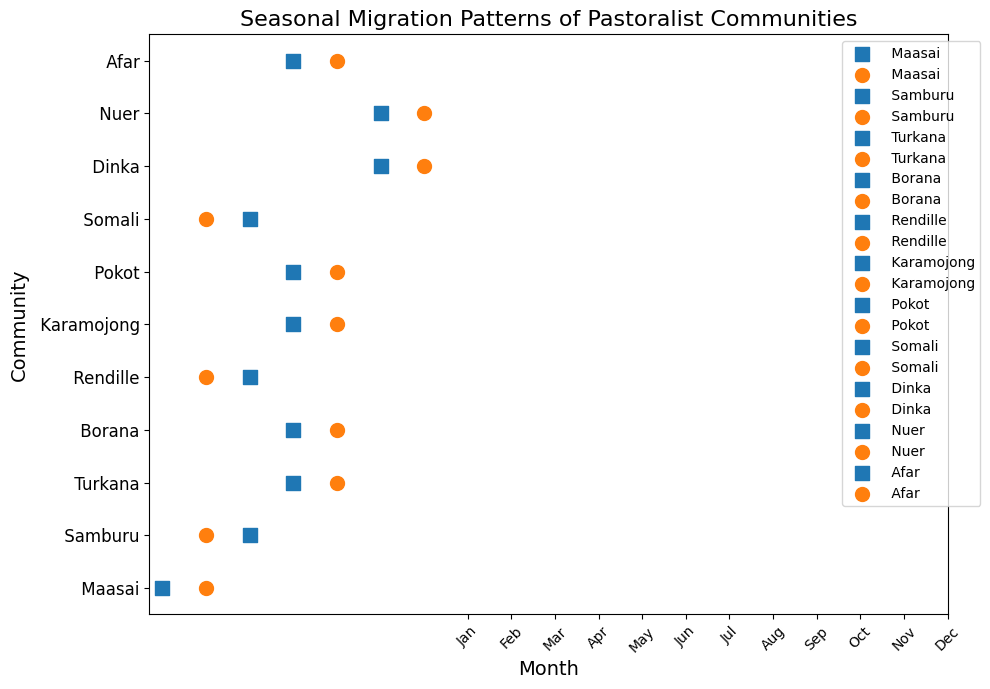Which community moves to dry season pastures the earliest in the year? From the scatter plot, observe that the first movement to dry season pastures occurs with the Dinka and Nuer communities in February.
Answer: Dinka and Nuer When do the Maasai community move to wet season pastures? In the scatter plot, locate the Maasai community row and find the month denoted with an orange circle. This occurs in November.
Answer: November Which communities move to dry season pastures in June? Identify the rows for June and note the communities with a blue square on their respective y-axis positions. These communities are Turkana, Borana, Karamojong, Pokot, and Afar.
Answer: Turkana, Borana, Karamojong, Pokot, Afar Do any communities move to wet season pastures in both October and November? From the scatter plot, check both October and November for communities with orange circles. Samburu, Turkana, Borana, Karamojong, Pokot, Afar move in October and Maasai, Rendille, Somali move in November. No community moves in both months.
Answer: No Which community has the northernmost seasonal pastures based on latitude? Check the scatter plot for the community with the highest latitude value on the y-axis. The Somali community has the highest latitude at 11.5000.
Answer: Somali Which communities move to dry season pastures in July? Observe the scatter plot bar for July and identify the communities with blue squares on their respective y-axis positions. They are Samburu, Rendille, and Somali.
Answer: Samburu, Rendille, Somali Do the Borana and Turkana communities move to wet season pastures in the same month? If yes, which month? Examine the months associated with orange circles for both Borana and Turkana. Both communities move to wet season pastures in October.
Answer: Yes, October Compare the months of seasonal migration to wet pastures for Dinka and Maasai communities. Which community moves first in the year? For the Dinka and Maasai communities, locate the months they migrate to wet pastures (orange circles). Dinka moves in May, while Maasai moves in November, making Dinka move first.
Answer: Dinka What is the average month for moving to wet season pastures for the Nuer community? Identify the months for the Nuer community (only events marked with orange circles). With only one event in May, the average is simply May.
Answer: May 